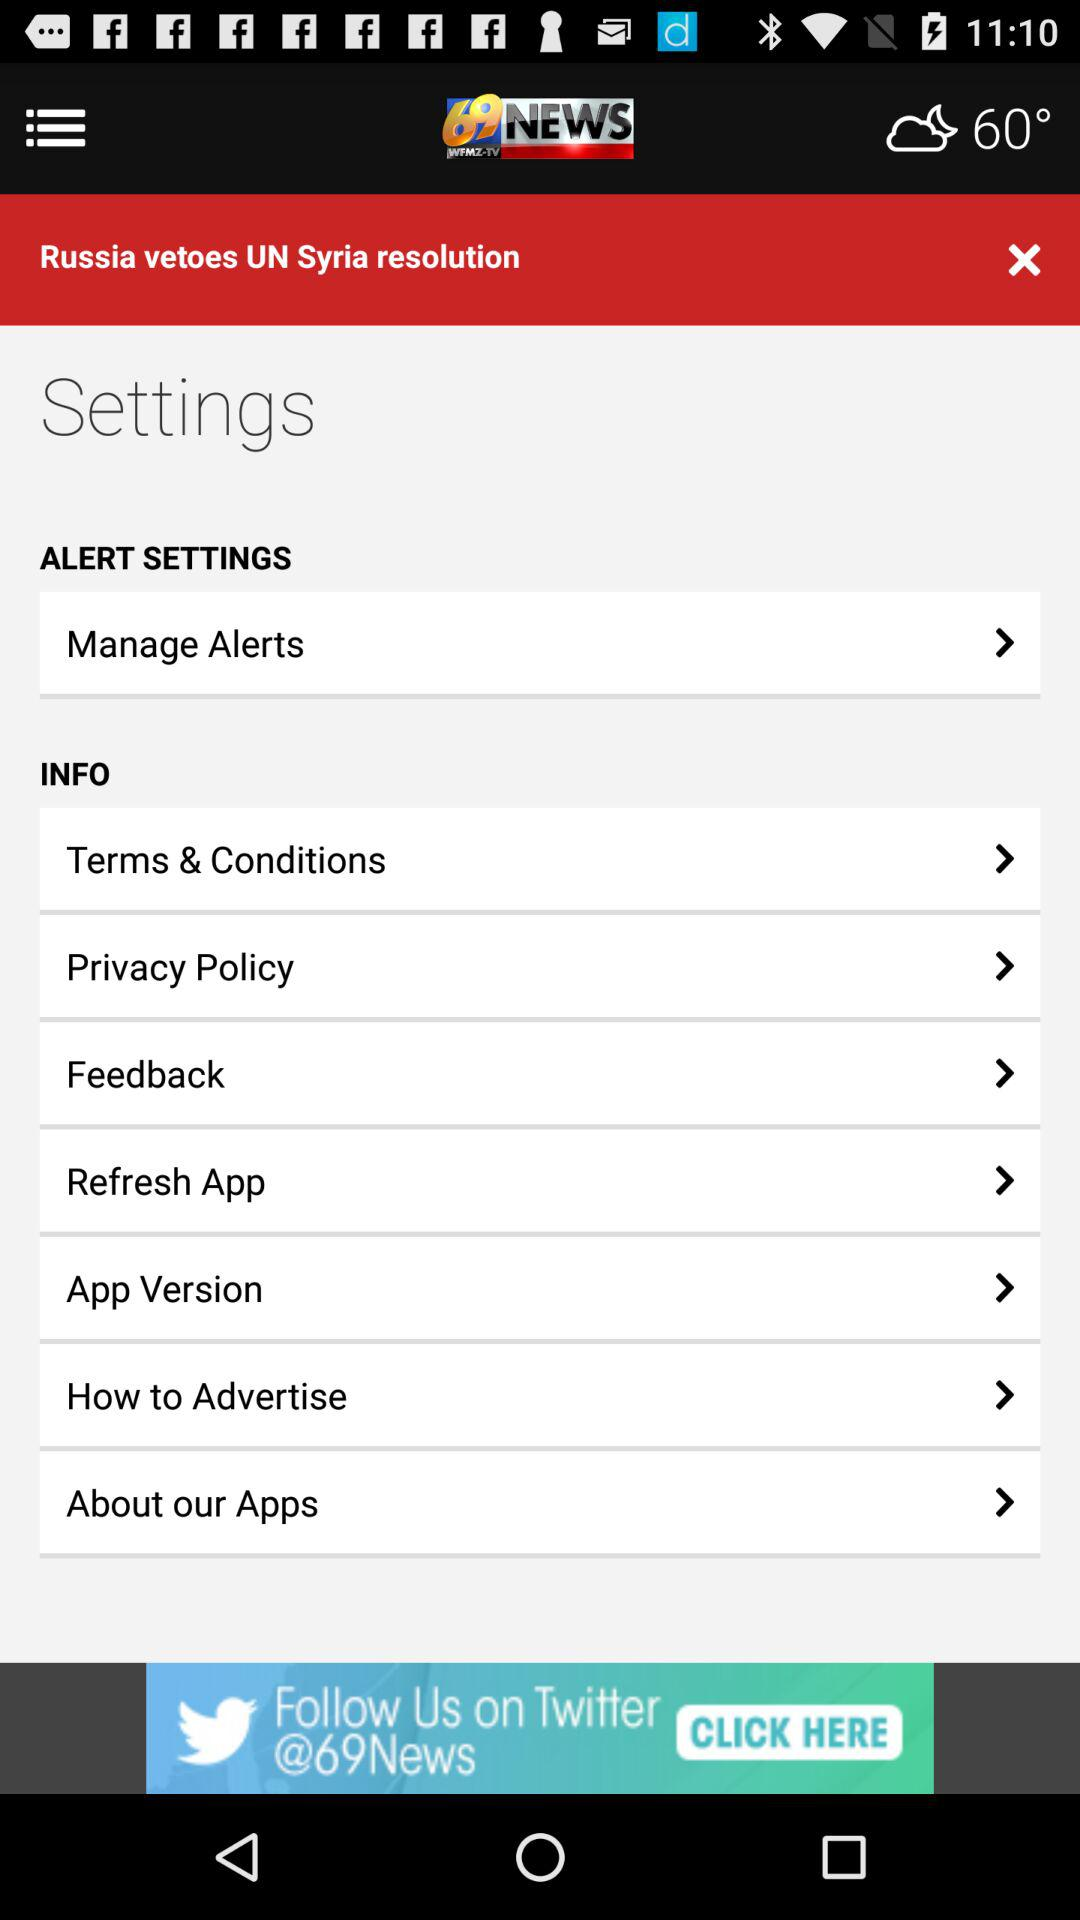What is the application name? The application name is "69News WX". 